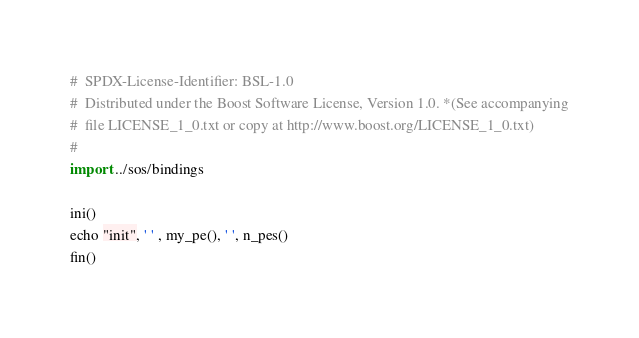Convert code to text. <code><loc_0><loc_0><loc_500><loc_500><_Nim_>#  SPDX-License-Identifier: BSL-1.0
#  Distributed under the Boost Software License, Version 1.0. *(See accompanying
#  file LICENSE_1_0.txt or copy at http://www.boost.org/LICENSE_1_0.txt)
#
import ../sos/bindings

ini()
echo "init", ' ' , my_pe(), ' ', n_pes()
fin()
</code> 